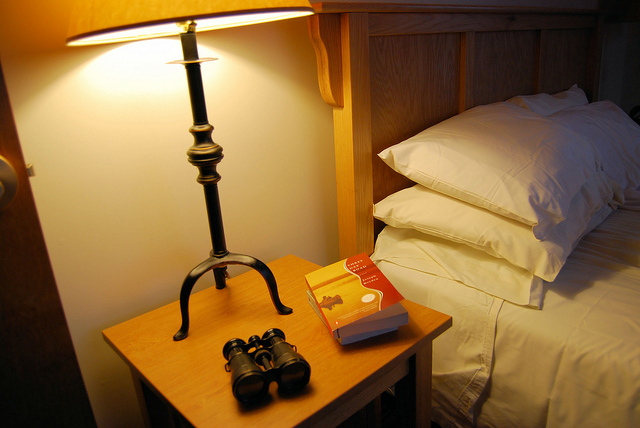What book is lying on the bedside table? The book on the bedside table has a red cover with what appears to be a camel design, suggesting it may be a travelogue or a novel set in an exotic location. 